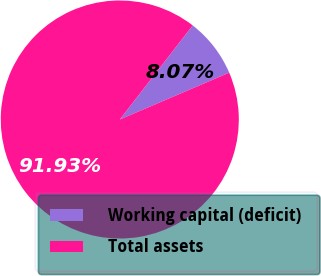Convert chart to OTSL. <chart><loc_0><loc_0><loc_500><loc_500><pie_chart><fcel>Working capital (deficit)<fcel>Total assets<nl><fcel>8.07%<fcel>91.93%<nl></chart> 